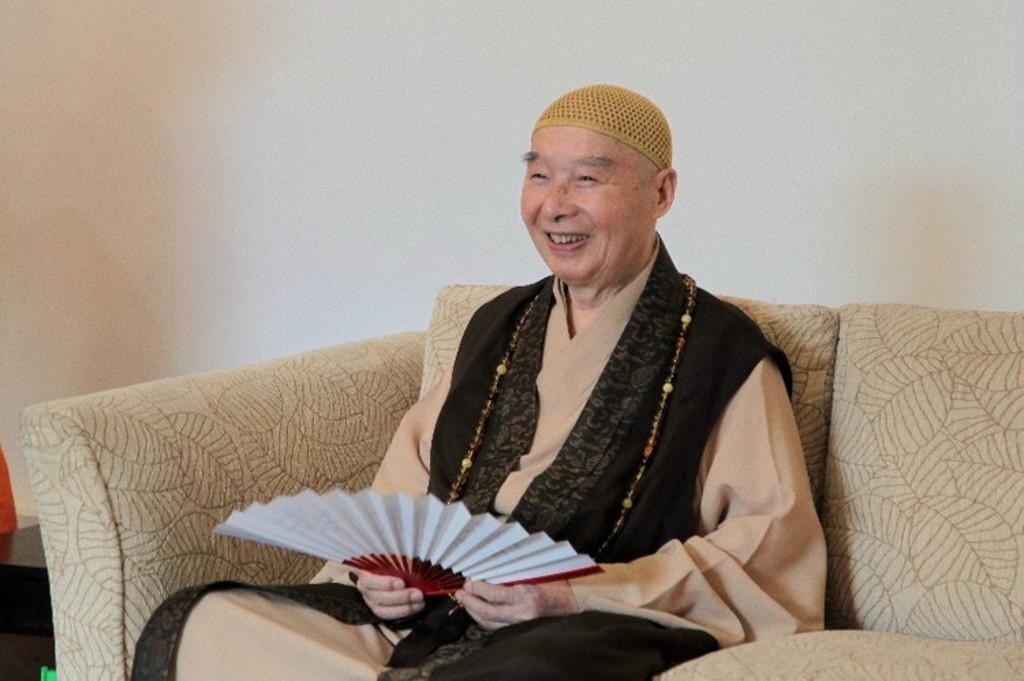Where was the image taken? The image was taken in a room. What is the person in the image doing? The person is sitting in a couch in the foreground of the image. What furniture can be seen on the left side of the image? There is a desk on the left side of the image. What color is the wall in the background of the image? The wall in the background is painted white. Can you see a kitten playing with a cat on the desk in the image? There is no kitten or cat present on the desk or anywhere else in the image. 